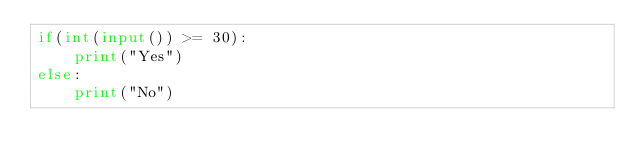<code> <loc_0><loc_0><loc_500><loc_500><_Python_>if(int(input()) >= 30):
	print("Yes")
else:
	print("No")</code> 